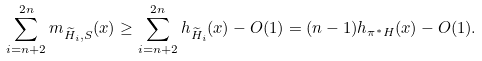<formula> <loc_0><loc_0><loc_500><loc_500>\sum _ { i = n + 2 } ^ { 2 n } m _ { \widetilde { H } _ { i } , S } ( x ) \geq \sum _ { i = n + 2 } ^ { 2 n } h _ { \widetilde { H } _ { i } } ( x ) - O ( 1 ) = ( n - 1 ) h _ { \pi ^ { * } H } ( x ) - O ( 1 ) .</formula> 